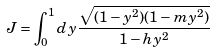Convert formula to latex. <formula><loc_0><loc_0><loc_500><loc_500>J = \int _ { 0 } ^ { 1 } d y \frac { \sqrt { ( 1 - y ^ { 2 } ) ( 1 - m y ^ { 2 } ) } } { 1 - h y ^ { 2 } }</formula> 